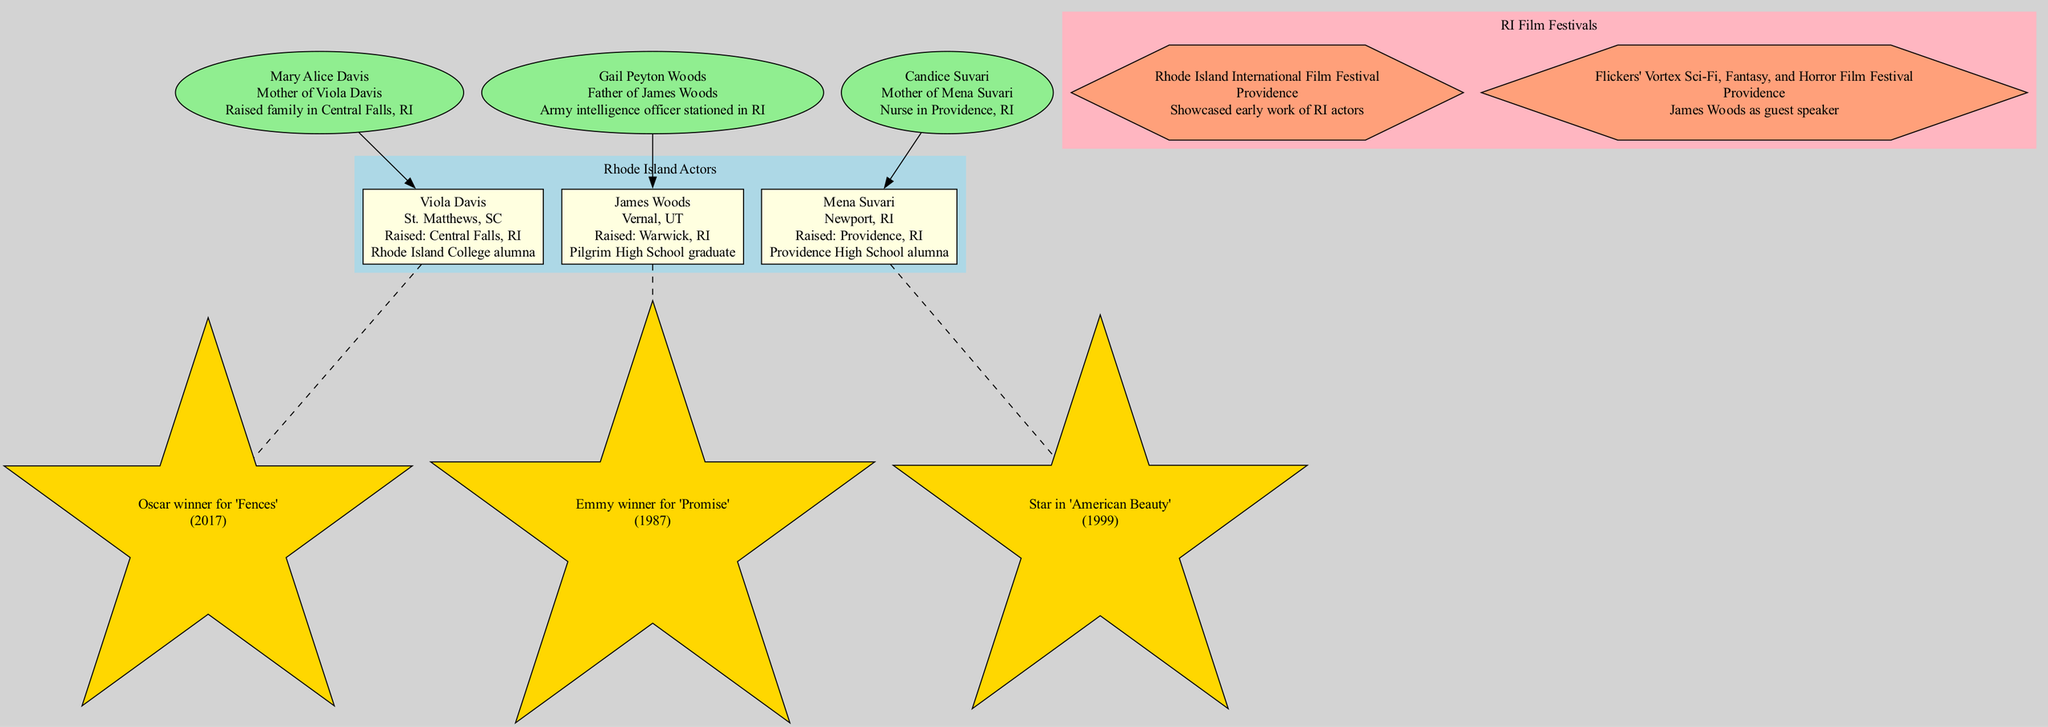What is the birthplace of Viola Davis? Viola Davis' birthplace is listed in the diagram as St. Matthews, SC.
Answer: St. Matthews, SC Which actor is connected to Rhode Island College? The connection information for Viola Davis indicates that she is an alumna of Rhode Island College.
Answer: Viola Davis How many actors are raised in Rhode Island? The diagram lists a total of three actors (Viola Davis, James Woods, Mena Suvari) and specifies that all three were raised in or connected to RI in some way.
Answer: 3 Who is the mother of Mena Suvari? The diagram shows that Mena Suvari's mother is Candice Suvari, noted as a nurse in Providence, RI.
Answer: Candice Suvari What year did Viola Davis win an Oscar? The connection for Viola Davis states she won an Oscar for "Fences" in 2017.
Answer: 2017 Which actor has a father who served in the Army? According to the diagram, James Woods’ father, Gail Peyton Woods, is noted as an Army intelligence officer stationed in RI.
Answer: James Woods What type of relationship does Mary Alice Davis have with Viola Davis? The diagram indicates that Mary Alice Davis is the mother of Viola Davis, establishing a direct familial relationship.
Answer: Mother What is the name of the film festival where James Woods was a guest speaker? The diagram specifies "Flickers' Vortex Sci-Fi, Fantasy, and Horror Film Festival" as the festival where James Woods appeared as a guest speaker.
Answer: Flickers' Vortex Sci-Fi, Fantasy, and Horror Film Festival Which actor starred in "American Beauty"? The information in the diagram clarifies that Mena Suvari starred in "American Beauty".
Answer: Mena Suvari 